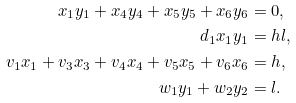<formula> <loc_0><loc_0><loc_500><loc_500>x _ { 1 } y _ { 1 } + x _ { 4 } y _ { 4 } + x _ { 5 } y _ { 5 } + x _ { 6 } y _ { 6 } & = 0 , \\ d _ { 1 } x _ { 1 } y _ { 1 } & = h l , \\ v _ { 1 } x _ { 1 } + v _ { 3 } x _ { 3 } + v _ { 4 } x _ { 4 } + v _ { 5 } x _ { 5 } + v _ { 6 } x _ { 6 } & = h , \\ w _ { 1 } y _ { 1 } + w _ { 2 } y _ { 2 } & = l .</formula> 